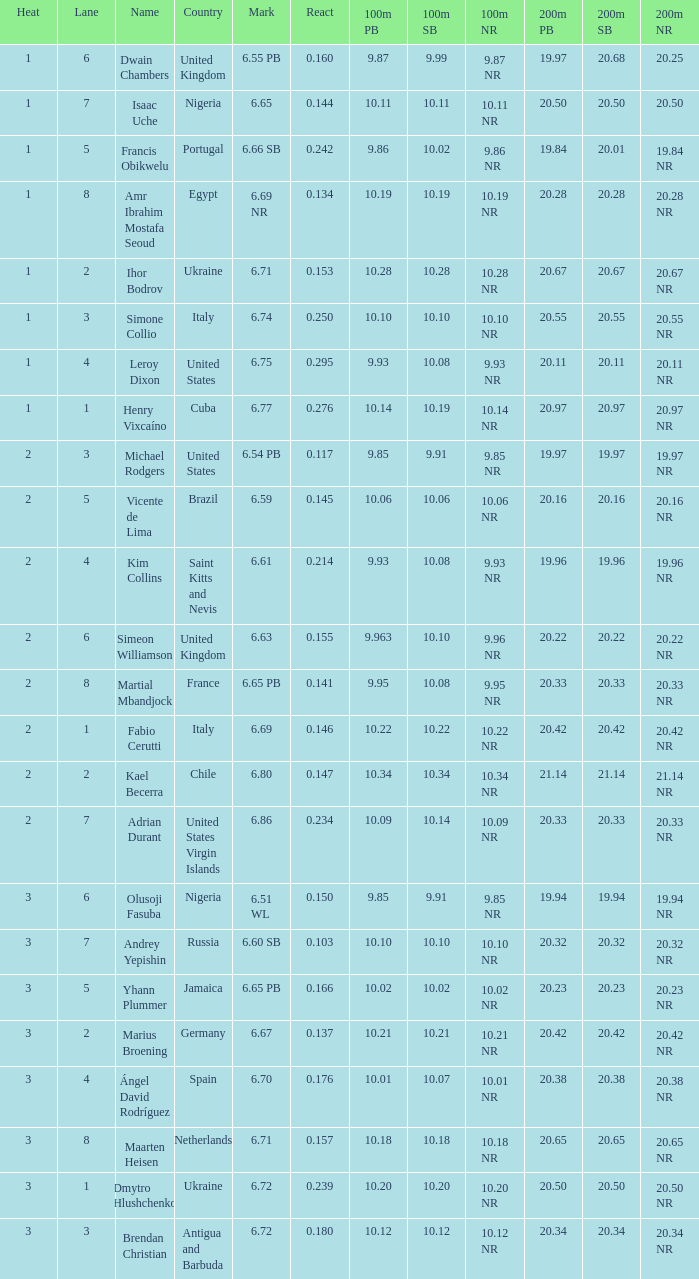What is Mark, when Name is Dmytro Hlushchenko? 6.72. 